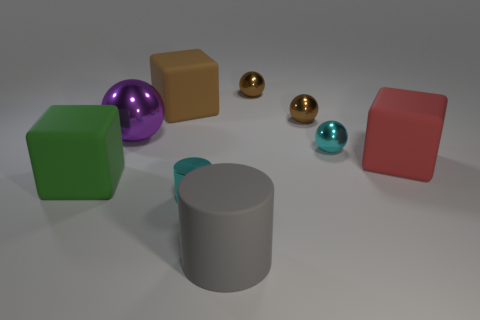Subtract 1 cubes. How many cubes are left? 2 Add 1 large brown cubes. How many objects exist? 10 Subtract all cylinders. How many objects are left? 7 Subtract 1 purple spheres. How many objects are left? 8 Subtract all small cyan rubber cylinders. Subtract all large purple metal objects. How many objects are left? 8 Add 9 cyan cylinders. How many cyan cylinders are left? 10 Add 8 red cylinders. How many red cylinders exist? 8 